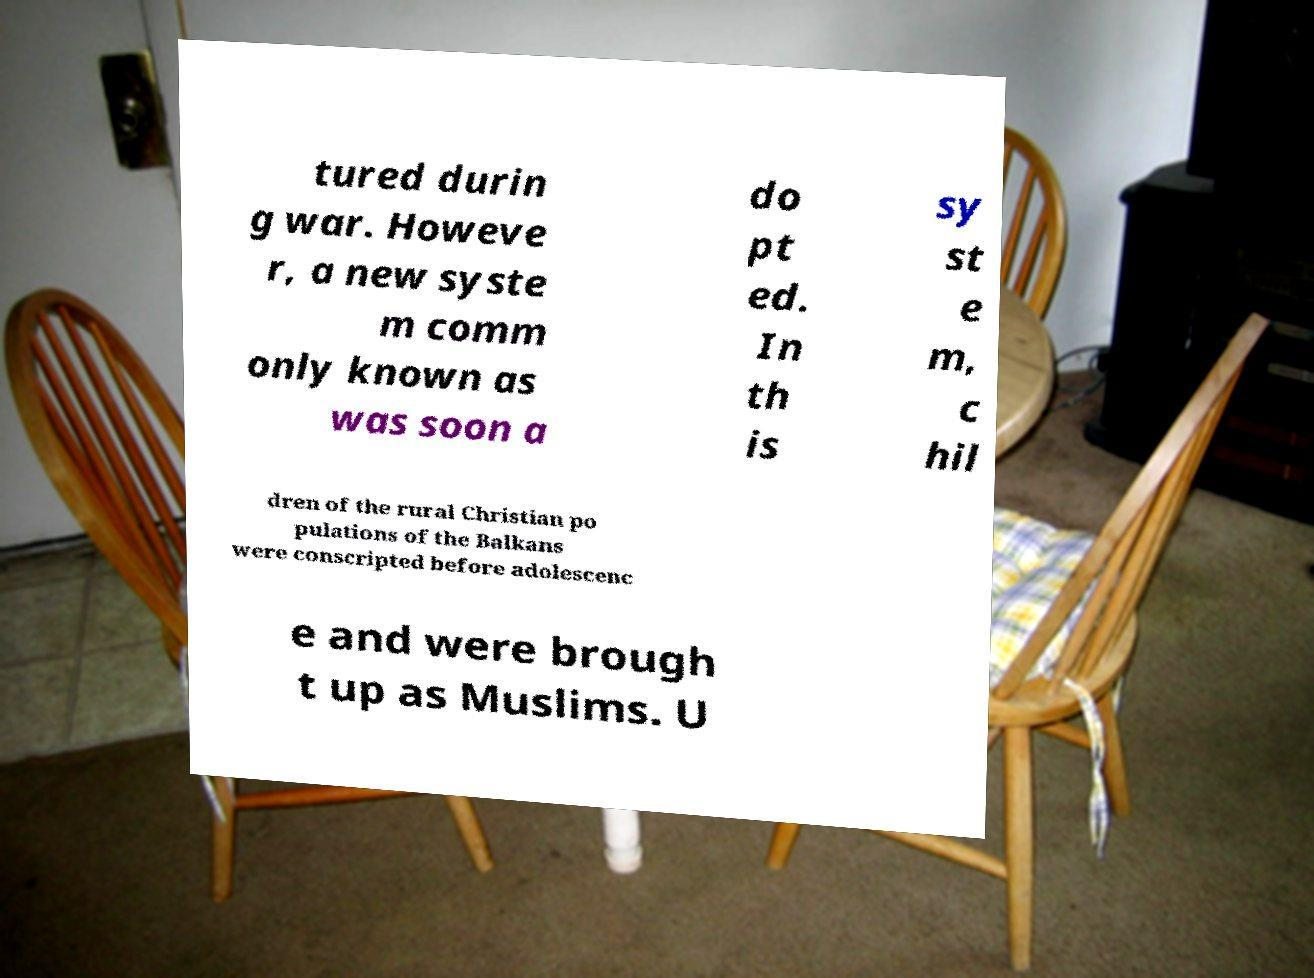There's text embedded in this image that I need extracted. Can you transcribe it verbatim? tured durin g war. Howeve r, a new syste m comm only known as was soon a do pt ed. In th is sy st e m, c hil dren of the rural Christian po pulations of the Balkans were conscripted before adolescenc e and were brough t up as Muslims. U 